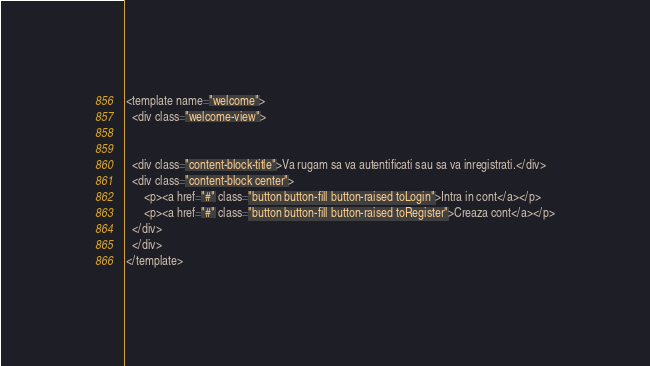<code> <loc_0><loc_0><loc_500><loc_500><_HTML_><template name="welcome">
  <div class="welcome-view">
    
  
  <div class="content-block-title">Va rugam sa va autentificati sau sa va inregistrati.</div>
  <div class="content-block center">
      <p><a href="#" class="button button-fill button-raised toLogin">Intra in cont</a></p>
      <p><a href="#" class="button button-fill button-raised toRegister">Creaza cont</a></p>
  </div>
  </div>
</template></code> 